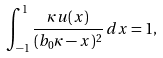<formula> <loc_0><loc_0><loc_500><loc_500>\int _ { - 1 } ^ { 1 } \frac { \kappa u ( x ) } { ( b _ { 0 } \kappa - x ) ^ { 2 } } \, d x = 1 ,</formula> 